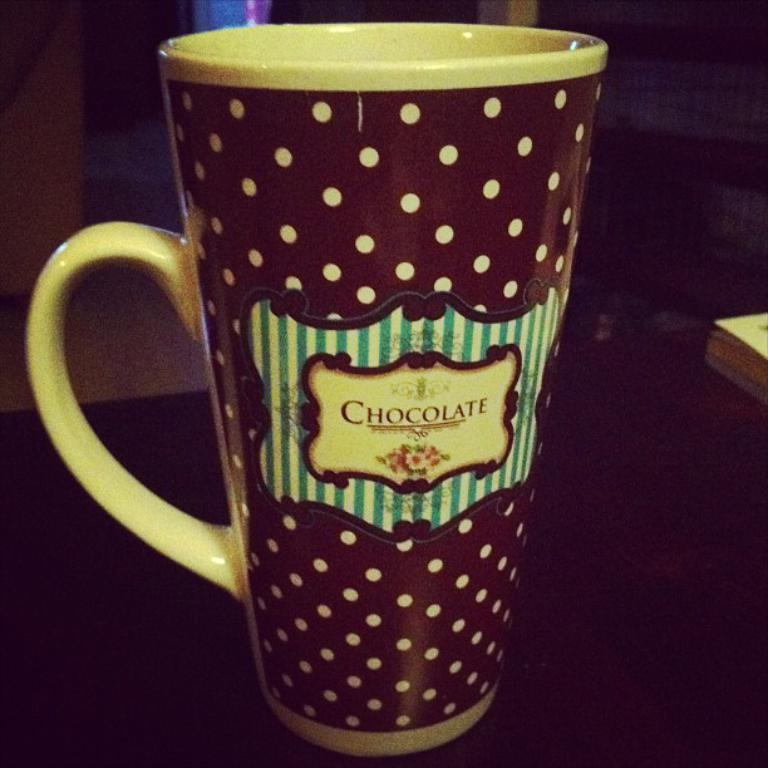<image>
Write a terse but informative summary of the picture. A colourful mug has chocolate written on its middle. 